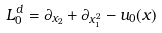Convert formula to latex. <formula><loc_0><loc_0><loc_500><loc_500>L _ { 0 } ^ { d } = \partial _ { x _ { 2 } } + \partial _ { x _ { 1 } ^ { 2 } } - u _ { 0 } ( x )</formula> 